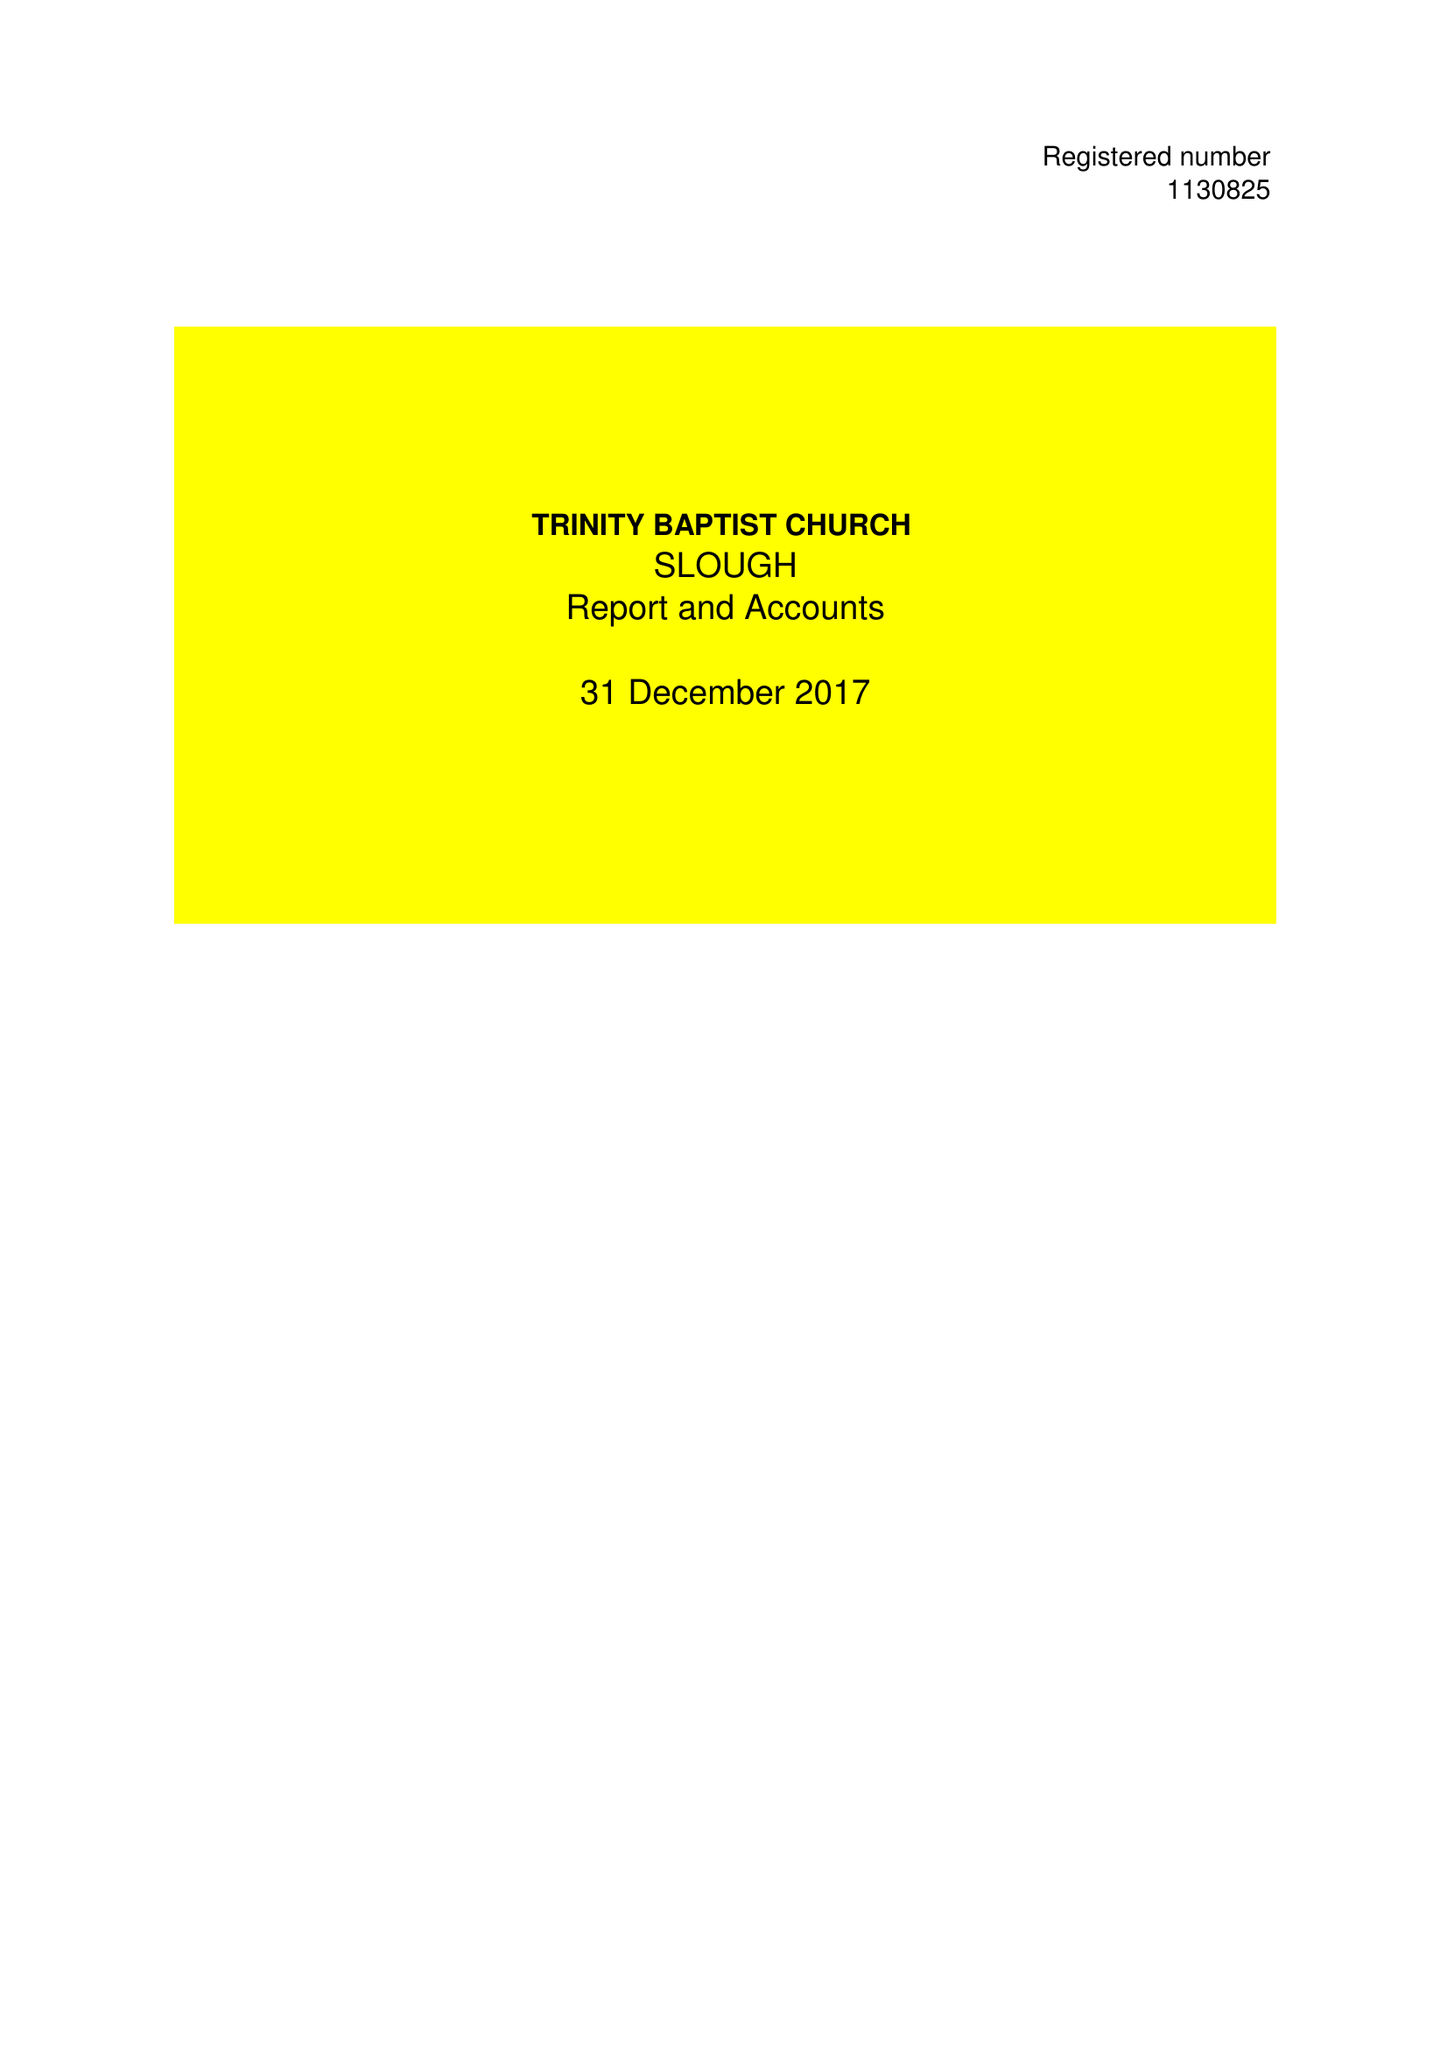What is the value for the charity_number?
Answer the question using a single word or phrase. 1130825 